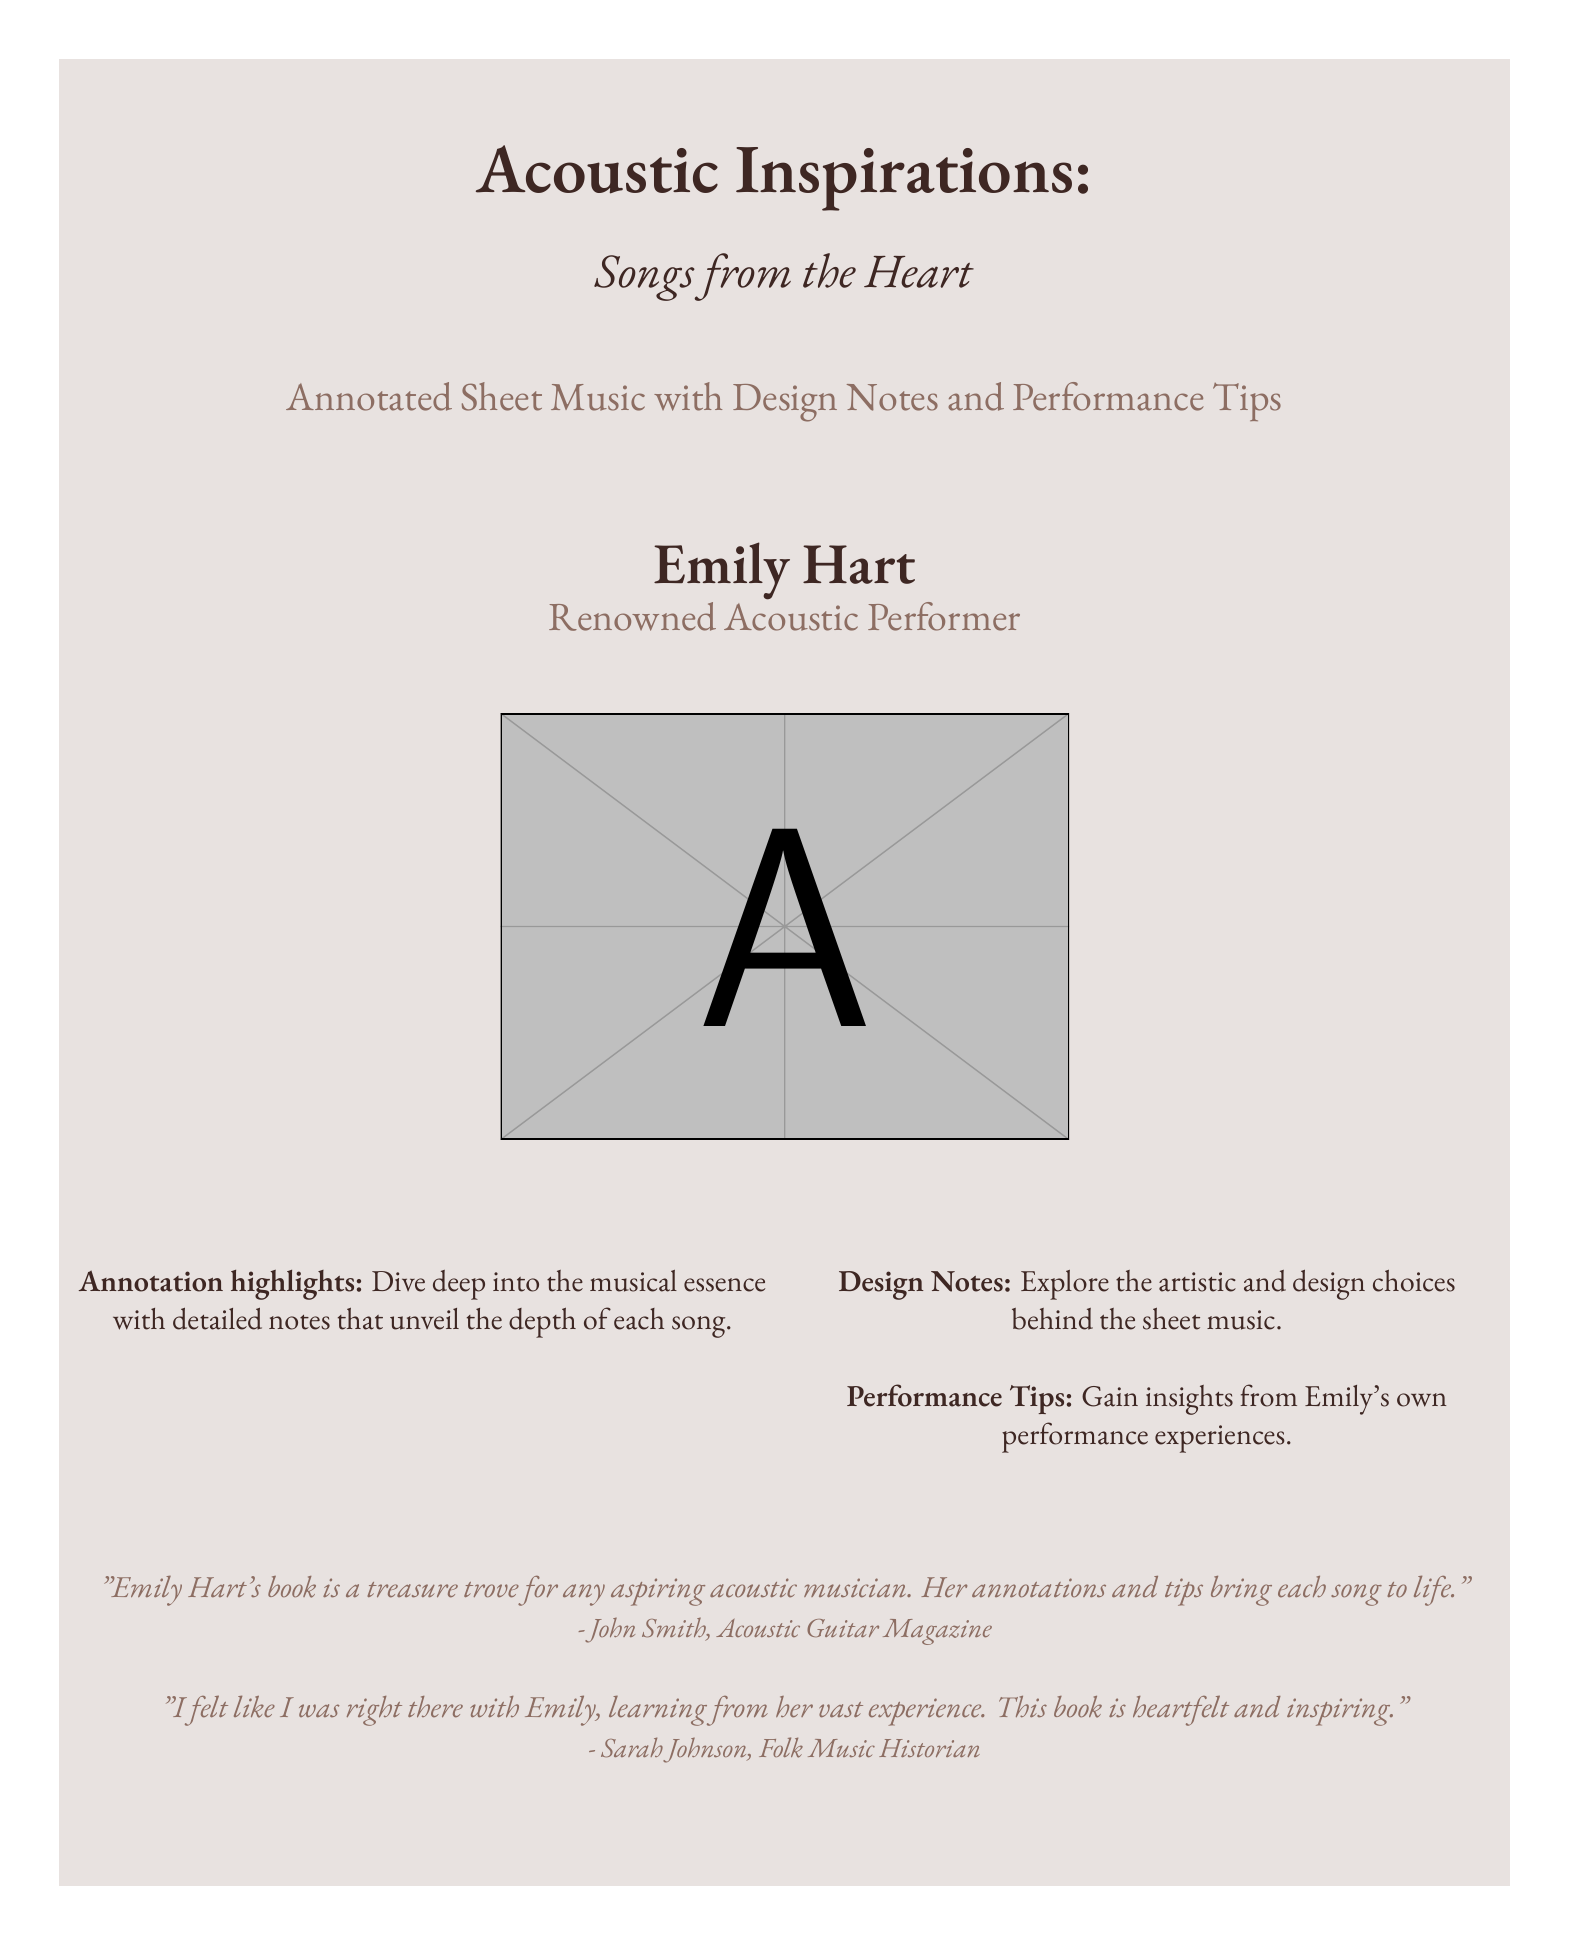What is the title of the book? The title of the book is prominently displayed in a large font, which is "Acoustic Inspirations."
Answer: Acoustic Inspirations Who is the author of the book? The author's name is mentioned below the title, identifying her as "Emily Hart."
Answer: Emily Hart What type of content does the book include? The book cover states it contains "Annotated Sheet Music with Design Notes and Performance Tips."
Answer: Annotated Sheet Music with Design Notes and Performance Tips What is the profession of Emily Hart as stated on the cover? The book presents Emily Hart as a "Renowned Acoustic Performer."
Answer: Renowned Acoustic Performer Which magazine featured a testimonial about the book? The testimonial included is from "Acoustic Guitar Magazine."
Answer: Acoustic Guitar Magazine What do the annotations in the book help to unveil? The annotations provide insights into the musical depth of the songs, as stated in the highlights.
Answer: The depth of each song What kind of tips does the book offer? The cover mentions offering "Performance Tips" gained from Emily's experiences.
Answer: Performance Tips Who provided a testimonial expressing personal experience from the book? The testimonial mentions a personal experience from "Sarah Johnson, Folk Music Historian."
Answer: Sarah Johnson What color is used for the primary text on the cover? The primary color used for the text is described using its hexadecimal code, which matches "primary."
Answer: 3E2723 